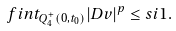Convert formula to latex. <formula><loc_0><loc_0><loc_500><loc_500>\ f i n t _ { Q _ { 4 } ^ { + } ( 0 , t _ { 0 } ) } | D v | ^ { p } \leq s i 1 .</formula> 